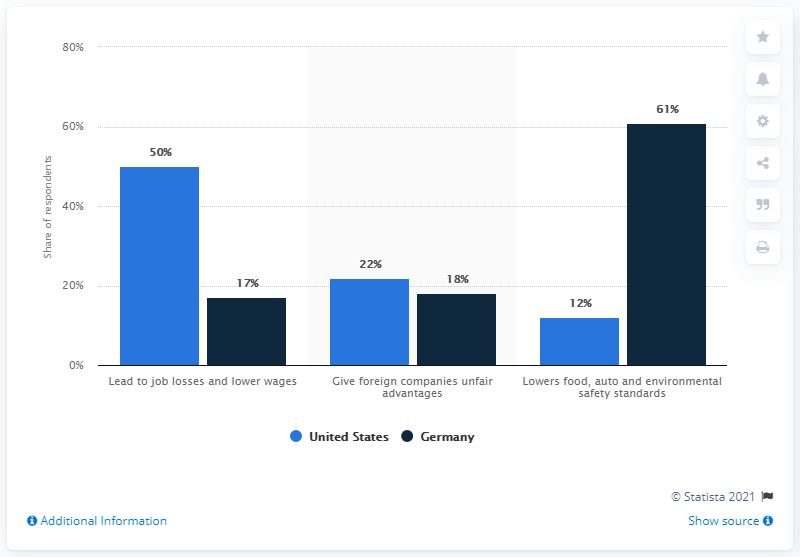Mention a couple of crucial points in this snapshot. According to a survey, 61% of Germans believed that TTIP would lower food, environment, and auto safety standards. 